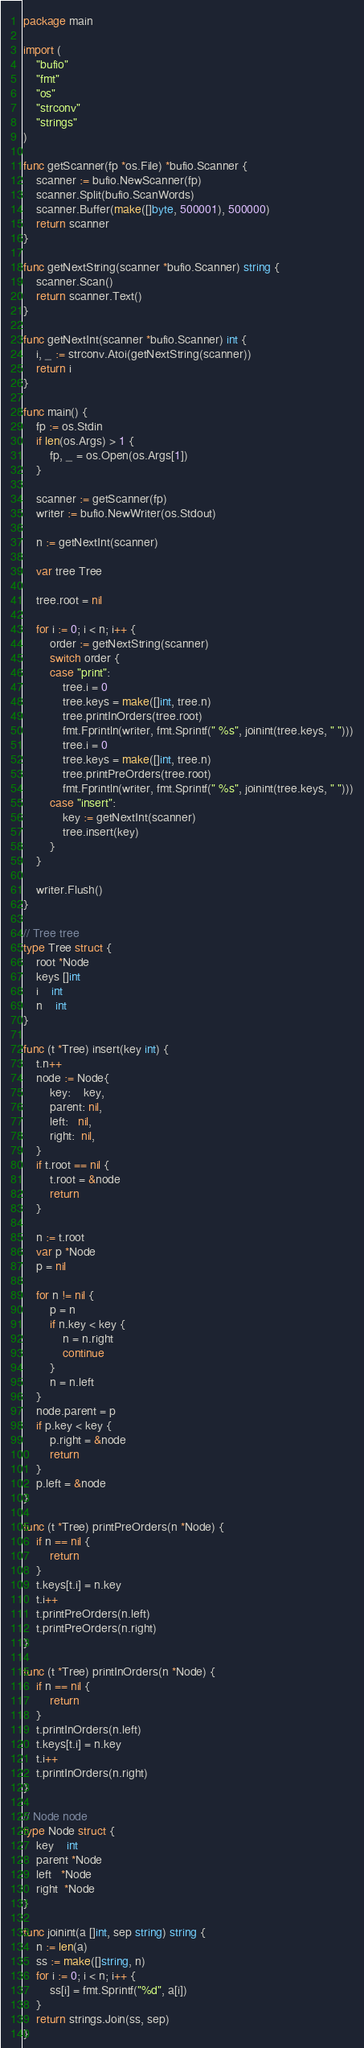Convert code to text. <code><loc_0><loc_0><loc_500><loc_500><_Go_>package main

import (
	"bufio"
	"fmt"
	"os"
	"strconv"
	"strings"
)

func getScanner(fp *os.File) *bufio.Scanner {
	scanner := bufio.NewScanner(fp)
	scanner.Split(bufio.ScanWords)
	scanner.Buffer(make([]byte, 500001), 500000)
	return scanner
}

func getNextString(scanner *bufio.Scanner) string {
	scanner.Scan()
	return scanner.Text()
}

func getNextInt(scanner *bufio.Scanner) int {
	i, _ := strconv.Atoi(getNextString(scanner))
	return i
}

func main() {
	fp := os.Stdin
	if len(os.Args) > 1 {
		fp, _ = os.Open(os.Args[1])
	}

	scanner := getScanner(fp)
	writer := bufio.NewWriter(os.Stdout)

	n := getNextInt(scanner)

	var tree Tree

	tree.root = nil

	for i := 0; i < n; i++ {
		order := getNextString(scanner)
		switch order {
		case "print":
			tree.i = 0
			tree.keys = make([]int, tree.n)
			tree.printInOrders(tree.root)
			fmt.Fprintln(writer, fmt.Sprintf(" %s", joinint(tree.keys, " ")))
			tree.i = 0
			tree.keys = make([]int, tree.n)
			tree.printPreOrders(tree.root)
			fmt.Fprintln(writer, fmt.Sprintf(" %s", joinint(tree.keys, " ")))
		case "insert":
			key := getNextInt(scanner)
			tree.insert(key)
		}
	}

	writer.Flush()
}

// Tree tree
type Tree struct {
	root *Node
	keys []int
	i    int
	n    int
}

func (t *Tree) insert(key int) {
	t.n++
	node := Node{
		key:    key,
		parent: nil,
		left:   nil,
		right:  nil,
	}
	if t.root == nil {
		t.root = &node
		return
	}

	n := t.root
	var p *Node
	p = nil

	for n != nil {
		p = n
		if n.key < key {
			n = n.right
			continue
		}
		n = n.left
	}
	node.parent = p
	if p.key < key {
		p.right = &node
		return
	}
	p.left = &node
}

func (t *Tree) printPreOrders(n *Node) {
	if n == nil {
		return
	}
	t.keys[t.i] = n.key
	t.i++
	t.printPreOrders(n.left)
	t.printPreOrders(n.right)
}

func (t *Tree) printInOrders(n *Node) {
	if n == nil {
		return
	}
	t.printInOrders(n.left)
	t.keys[t.i] = n.key
	t.i++
	t.printInOrders(n.right)
}

// Node node
type Node struct {
	key    int
	parent *Node
	left   *Node
	right  *Node
}

func joinint(a []int, sep string) string {
	n := len(a)
	ss := make([]string, n)
	for i := 0; i < n; i++ {
		ss[i] = fmt.Sprintf("%d", a[i])
	}
	return strings.Join(ss, sep)
}

</code> 